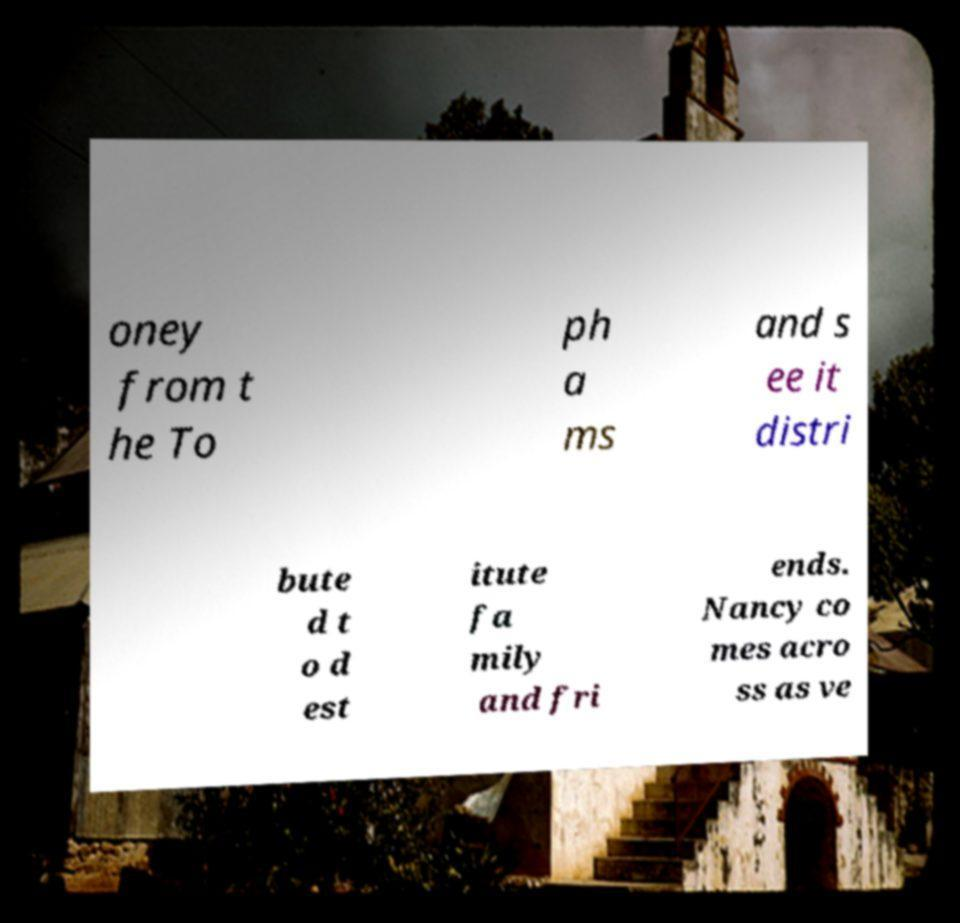I need the written content from this picture converted into text. Can you do that? oney from t he To ph a ms and s ee it distri bute d t o d est itute fa mily and fri ends. Nancy co mes acro ss as ve 